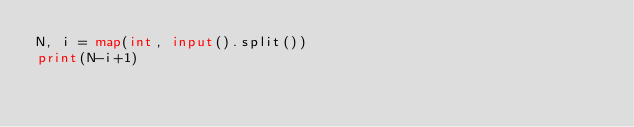Convert code to text. <code><loc_0><loc_0><loc_500><loc_500><_Python_>N, i = map(int, input().split())
print(N-i+1)</code> 